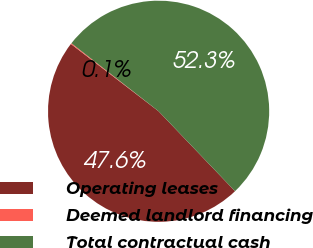Convert chart. <chart><loc_0><loc_0><loc_500><loc_500><pie_chart><fcel>Operating leases<fcel>Deemed landlord financing<fcel>Total contractual cash<nl><fcel>47.56%<fcel>0.13%<fcel>52.31%<nl></chart> 